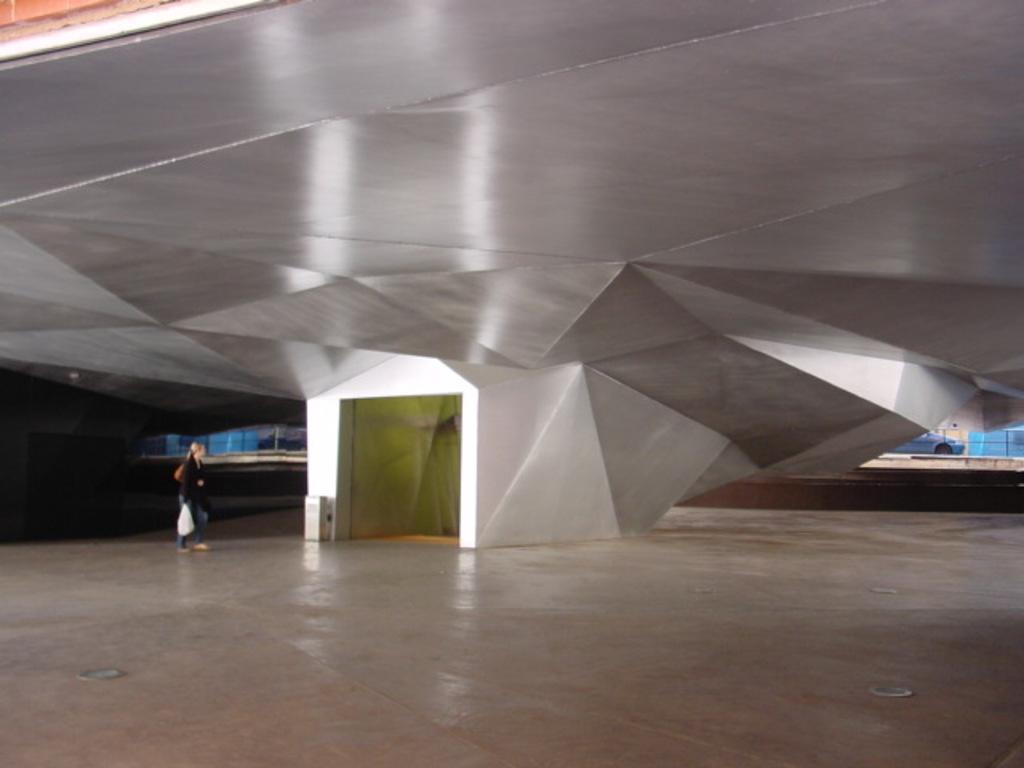Can you describe this image briefly? In this image, we can see a person holding a cover bag. We can see iron roof and a door. We can see the ground and a vehicle. 